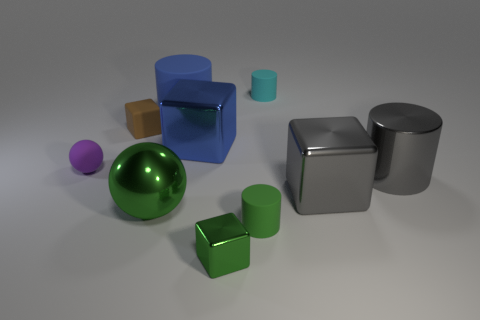There is a ball on the left side of the ball in front of the gray cylinder in front of the blue metal cube; what color is it?
Offer a very short reply. Purple. How many yellow objects are either large metal spheres or big matte cylinders?
Provide a short and direct response. 0. How many other objects are the same size as the gray cylinder?
Provide a short and direct response. 4. What number of purple spheres are there?
Provide a succinct answer. 1. Is there any other thing that has the same shape as the small brown matte object?
Offer a terse response. Yes. Does the cylinder that is in front of the big gray cylinder have the same material as the tiny cube behind the small metal object?
Your answer should be very brief. Yes. What is the brown cube made of?
Ensure brevity in your answer.  Rubber. How many small spheres have the same material as the tiny brown cube?
Offer a very short reply. 1. What number of metallic things are either green objects or large blue things?
Your answer should be compact. 3. Do the tiny matte object that is to the left of the brown matte cube and the small matte thing that is in front of the purple ball have the same shape?
Ensure brevity in your answer.  No. 